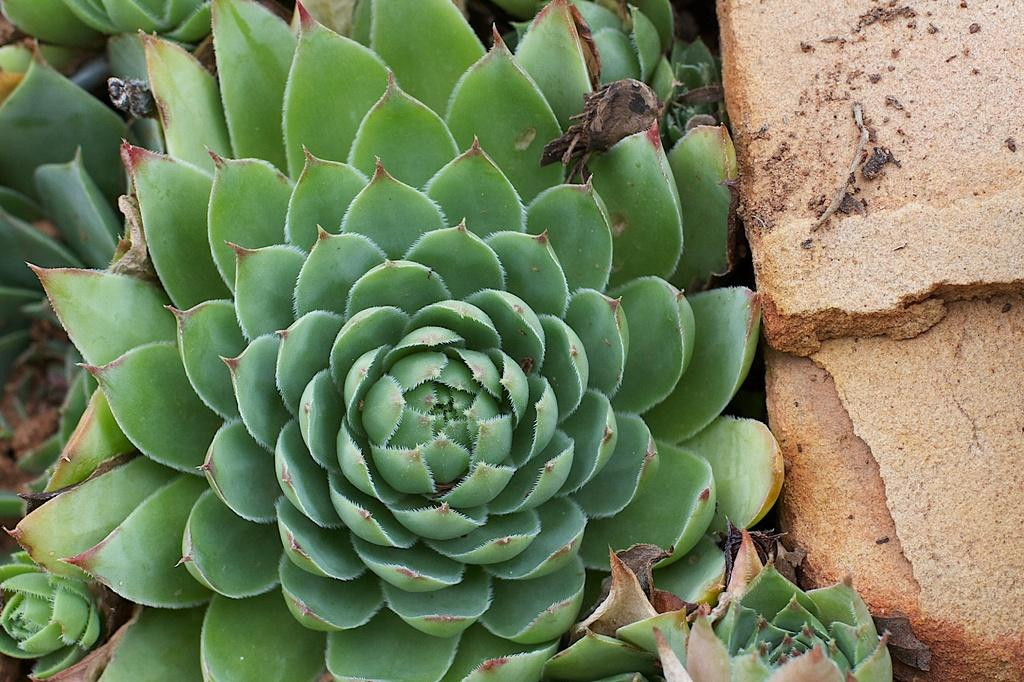What type of living organisms can be seen in the image? Plants can be seen in the image. What can be found on the right side of the image? There are stones on the right side of the image. How many copies of the plant can be seen in the image? There is no indication of multiple copies of the plant in the image; it appears to be a single plant. Is there a knot tied in any of the plants in the image? There is no knot present in the image; the plants are depicted in their natural state. 